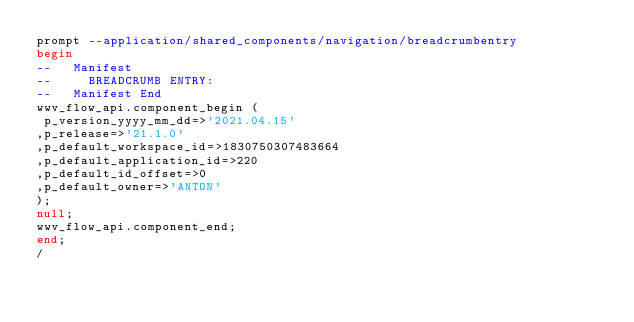<code> <loc_0><loc_0><loc_500><loc_500><_SQL_>prompt --application/shared_components/navigation/breadcrumbentry
begin
--   Manifest
--     BREADCRUMB ENTRY: 
--   Manifest End
wwv_flow_api.component_begin (
 p_version_yyyy_mm_dd=>'2021.04.15'
,p_release=>'21.1.0'
,p_default_workspace_id=>1830750307483664
,p_default_application_id=>220
,p_default_id_offset=>0
,p_default_owner=>'ANTON'
);
null;
wwv_flow_api.component_end;
end;
/
</code> 